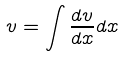Convert formula to latex. <formula><loc_0><loc_0><loc_500><loc_500>v = \int \frac { d v } { d x } d x</formula> 